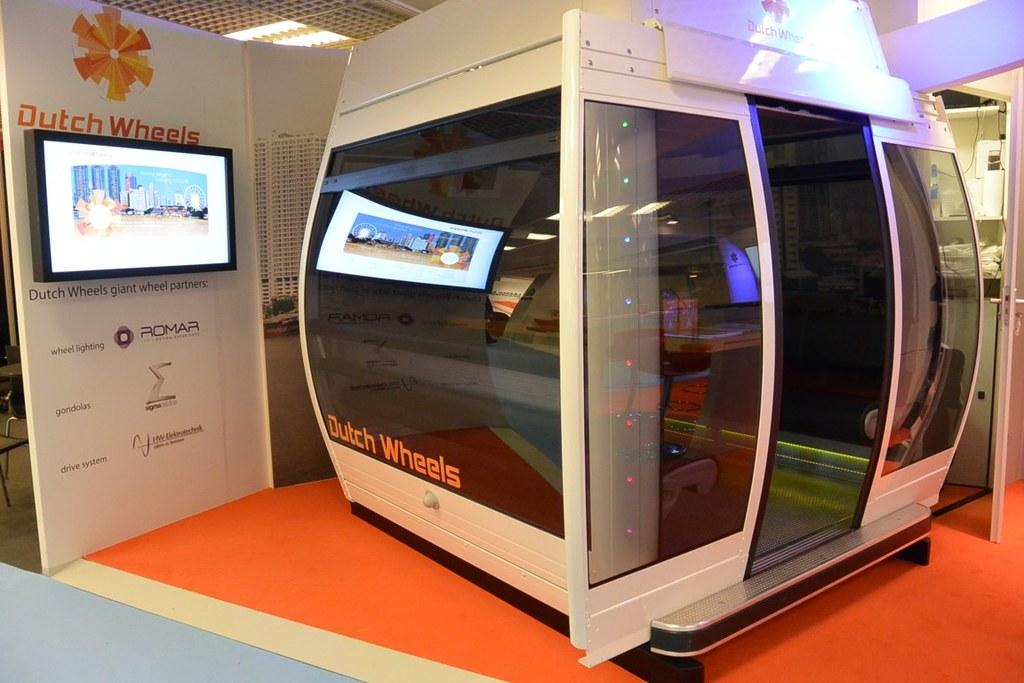What is the main object in the image? There is a machine in the image. What accompanies the machine in the image? There are glasses for the machine in the image. What can be seen on the left side of the image? There is a TV on the left side of the image. How many men are cooking on the stove in the image? There is no stove or men present in the image. What type of man is depicted in the image? There is no man depicted in the image. 